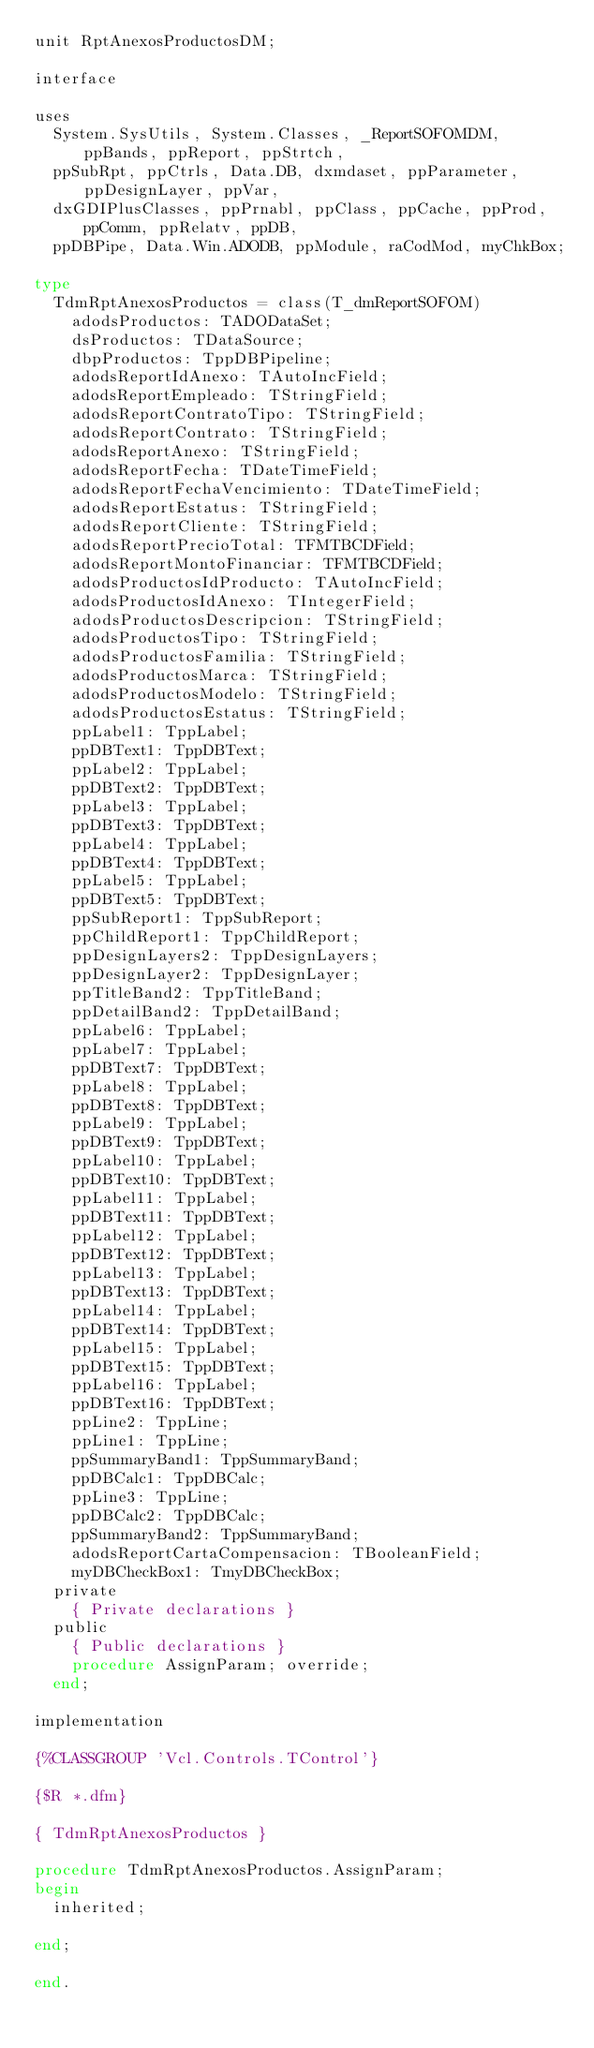Convert code to text. <code><loc_0><loc_0><loc_500><loc_500><_Pascal_>unit RptAnexosProductosDM;

interface

uses
  System.SysUtils, System.Classes, _ReportSOFOMDM, ppBands, ppReport, ppStrtch,
  ppSubRpt, ppCtrls, Data.DB, dxmdaset, ppParameter, ppDesignLayer, ppVar,
  dxGDIPlusClasses, ppPrnabl, ppClass, ppCache, ppProd, ppComm, ppRelatv, ppDB,
  ppDBPipe, Data.Win.ADODB, ppModule, raCodMod, myChkBox;

type
  TdmRptAnexosProductos = class(T_dmReportSOFOM)
    adodsProductos: TADODataSet;
    dsProductos: TDataSource;
    dbpProductos: TppDBPipeline;
    adodsReportIdAnexo: TAutoIncField;
    adodsReportEmpleado: TStringField;
    adodsReportContratoTipo: TStringField;
    adodsReportContrato: TStringField;
    adodsReportAnexo: TStringField;
    adodsReportFecha: TDateTimeField;
    adodsReportFechaVencimiento: TDateTimeField;
    adodsReportEstatus: TStringField;
    adodsReportCliente: TStringField;
    adodsReportPrecioTotal: TFMTBCDField;
    adodsReportMontoFinanciar: TFMTBCDField;
    adodsProductosIdProducto: TAutoIncField;
    adodsProductosIdAnexo: TIntegerField;
    adodsProductosDescripcion: TStringField;
    adodsProductosTipo: TStringField;
    adodsProductosFamilia: TStringField;
    adodsProductosMarca: TStringField;
    adodsProductosModelo: TStringField;
    adodsProductosEstatus: TStringField;
    ppLabel1: TppLabel;
    ppDBText1: TppDBText;
    ppLabel2: TppLabel;
    ppDBText2: TppDBText;
    ppLabel3: TppLabel;
    ppDBText3: TppDBText;
    ppLabel4: TppLabel;
    ppDBText4: TppDBText;
    ppLabel5: TppLabel;
    ppDBText5: TppDBText;
    ppSubReport1: TppSubReport;
    ppChildReport1: TppChildReport;
    ppDesignLayers2: TppDesignLayers;
    ppDesignLayer2: TppDesignLayer;
    ppTitleBand2: TppTitleBand;
    ppDetailBand2: TppDetailBand;
    ppLabel6: TppLabel;
    ppLabel7: TppLabel;
    ppDBText7: TppDBText;
    ppLabel8: TppLabel;
    ppDBText8: TppDBText;
    ppLabel9: TppLabel;
    ppDBText9: TppDBText;
    ppLabel10: TppLabel;
    ppDBText10: TppDBText;
    ppLabel11: TppLabel;
    ppDBText11: TppDBText;
    ppLabel12: TppLabel;
    ppDBText12: TppDBText;
    ppLabel13: TppLabel;
    ppDBText13: TppDBText;
    ppLabel14: TppLabel;
    ppDBText14: TppDBText;
    ppLabel15: TppLabel;
    ppDBText15: TppDBText;
    ppLabel16: TppLabel;
    ppDBText16: TppDBText;
    ppLine2: TppLine;
    ppLine1: TppLine;
    ppSummaryBand1: TppSummaryBand;
    ppDBCalc1: TppDBCalc;
    ppLine3: TppLine;
    ppDBCalc2: TppDBCalc;
    ppSummaryBand2: TppSummaryBand;
    adodsReportCartaCompensacion: TBooleanField;
    myDBCheckBox1: TmyDBCheckBox;
  private
    { Private declarations }
  public
    { Public declarations }
    procedure AssignParam; override;
  end;

implementation

{%CLASSGROUP 'Vcl.Controls.TControl'}

{$R *.dfm}

{ TdmRptAnexosProductos }

procedure TdmRptAnexosProductos.AssignParam;
begin
  inherited;

end;

end.
</code> 